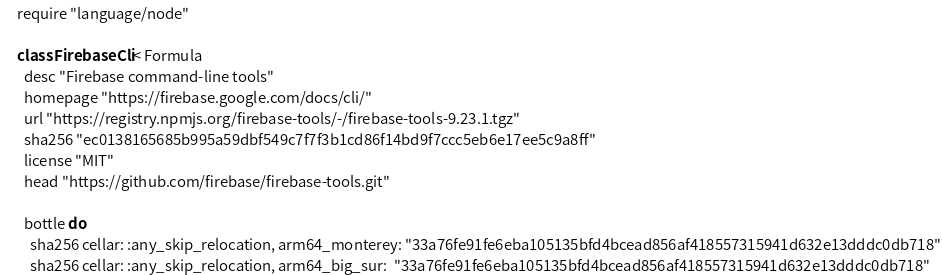Convert code to text. <code><loc_0><loc_0><loc_500><loc_500><_Ruby_>require "language/node"

class FirebaseCli < Formula
  desc "Firebase command-line tools"
  homepage "https://firebase.google.com/docs/cli/"
  url "https://registry.npmjs.org/firebase-tools/-/firebase-tools-9.23.1.tgz"
  sha256 "ec0138165685b995a59dbf549c7f7f3b1cd86f14bd9f7ccc5eb6e17ee5c9a8ff"
  license "MIT"
  head "https://github.com/firebase/firebase-tools.git"

  bottle do
    sha256 cellar: :any_skip_relocation, arm64_monterey: "33a76fe91fe6eba105135bfd4bcead856af418557315941d632e13dddc0db718"
    sha256 cellar: :any_skip_relocation, arm64_big_sur:  "33a76fe91fe6eba105135bfd4bcead856af418557315941d632e13dddc0db718"</code> 